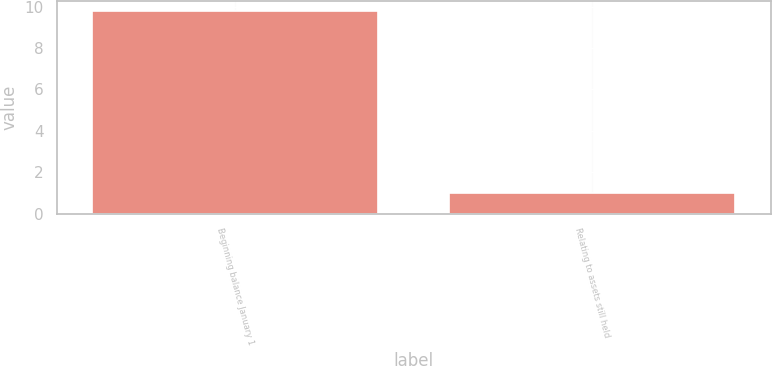Convert chart. <chart><loc_0><loc_0><loc_500><loc_500><bar_chart><fcel>Beginning balance January 1<fcel>Relating to assets still held<nl><fcel>9.8<fcel>1<nl></chart> 